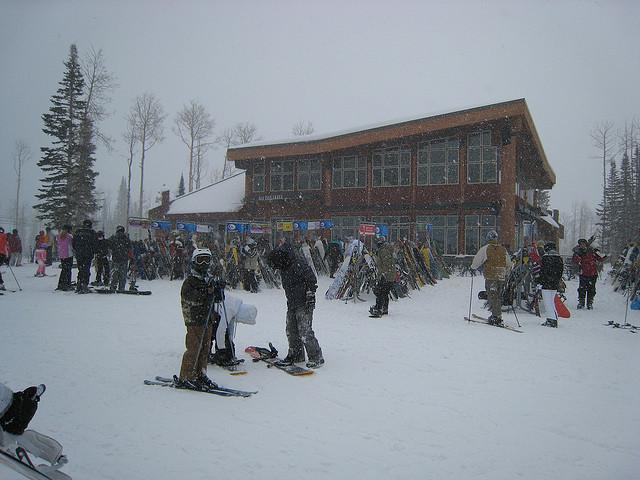What are the people in this photo doing?
Write a very short answer. Skiing. What is on the ground?
Concise answer only. Snow. How is the weather?
Write a very short answer. Snowy. Is it snowing?
Write a very short answer. Yes. How many poles are in the snow?
Short answer required. Lots. 